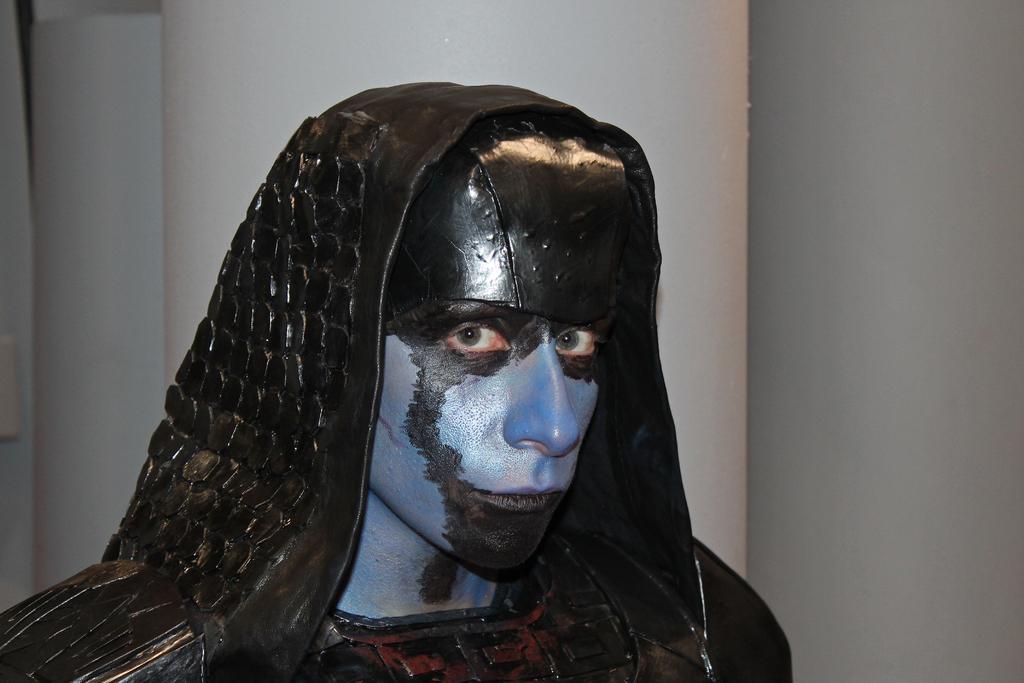Can you describe this image briefly? This image consists of a man and in the center. In the background there is a wall which is white in colour. 